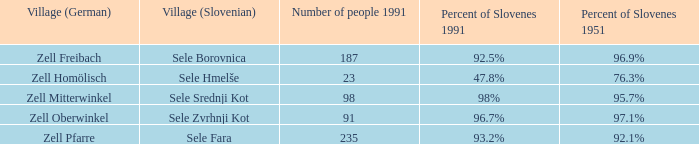Identify the german village that had a 9 Zell Freibach. 